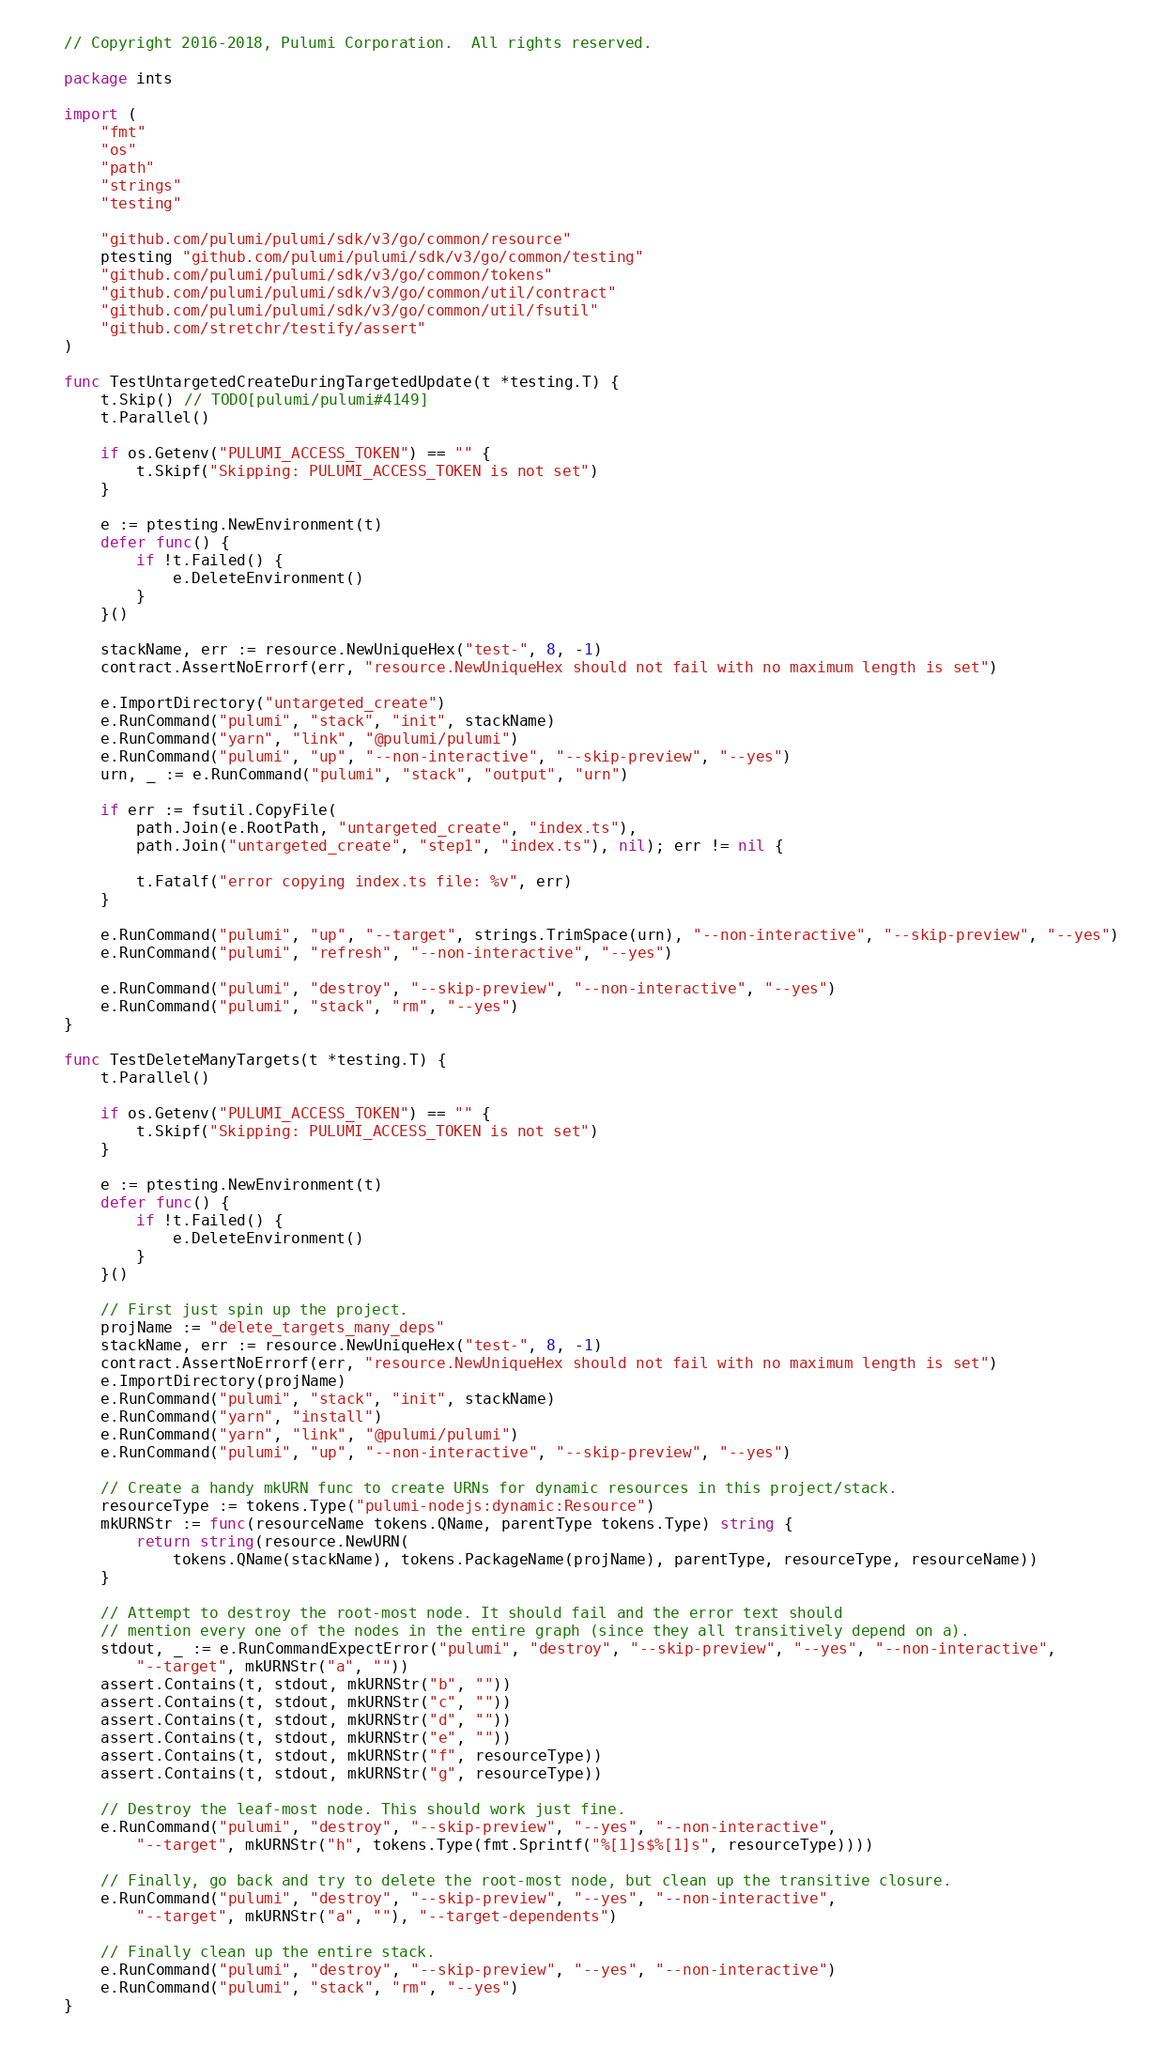Convert code to text. <code><loc_0><loc_0><loc_500><loc_500><_Go_>// Copyright 2016-2018, Pulumi Corporation.  All rights reserved.

package ints

import (
	"fmt"
	"os"
	"path"
	"strings"
	"testing"

	"github.com/pulumi/pulumi/sdk/v3/go/common/resource"
	ptesting "github.com/pulumi/pulumi/sdk/v3/go/common/testing"
	"github.com/pulumi/pulumi/sdk/v3/go/common/tokens"
	"github.com/pulumi/pulumi/sdk/v3/go/common/util/contract"
	"github.com/pulumi/pulumi/sdk/v3/go/common/util/fsutil"
	"github.com/stretchr/testify/assert"
)

func TestUntargetedCreateDuringTargetedUpdate(t *testing.T) {
	t.Skip() // TODO[pulumi/pulumi#4149]
	t.Parallel()

	if os.Getenv("PULUMI_ACCESS_TOKEN") == "" {
		t.Skipf("Skipping: PULUMI_ACCESS_TOKEN is not set")
	}

	e := ptesting.NewEnvironment(t)
	defer func() {
		if !t.Failed() {
			e.DeleteEnvironment()
		}
	}()

	stackName, err := resource.NewUniqueHex("test-", 8, -1)
	contract.AssertNoErrorf(err, "resource.NewUniqueHex should not fail with no maximum length is set")

	e.ImportDirectory("untargeted_create")
	e.RunCommand("pulumi", "stack", "init", stackName)
	e.RunCommand("yarn", "link", "@pulumi/pulumi")
	e.RunCommand("pulumi", "up", "--non-interactive", "--skip-preview", "--yes")
	urn, _ := e.RunCommand("pulumi", "stack", "output", "urn")

	if err := fsutil.CopyFile(
		path.Join(e.RootPath, "untargeted_create", "index.ts"),
		path.Join("untargeted_create", "step1", "index.ts"), nil); err != nil {

		t.Fatalf("error copying index.ts file: %v", err)
	}

	e.RunCommand("pulumi", "up", "--target", strings.TrimSpace(urn), "--non-interactive", "--skip-preview", "--yes")
	e.RunCommand("pulumi", "refresh", "--non-interactive", "--yes")

	e.RunCommand("pulumi", "destroy", "--skip-preview", "--non-interactive", "--yes")
	e.RunCommand("pulumi", "stack", "rm", "--yes")
}

func TestDeleteManyTargets(t *testing.T) {
	t.Parallel()

	if os.Getenv("PULUMI_ACCESS_TOKEN") == "" {
		t.Skipf("Skipping: PULUMI_ACCESS_TOKEN is not set")
	}

	e := ptesting.NewEnvironment(t)
	defer func() {
		if !t.Failed() {
			e.DeleteEnvironment()
		}
	}()

	// First just spin up the project.
	projName := "delete_targets_many_deps"
	stackName, err := resource.NewUniqueHex("test-", 8, -1)
	contract.AssertNoErrorf(err, "resource.NewUniqueHex should not fail with no maximum length is set")
	e.ImportDirectory(projName)
	e.RunCommand("pulumi", "stack", "init", stackName)
	e.RunCommand("yarn", "install")
	e.RunCommand("yarn", "link", "@pulumi/pulumi")
	e.RunCommand("pulumi", "up", "--non-interactive", "--skip-preview", "--yes")

	// Create a handy mkURN func to create URNs for dynamic resources in this project/stack.
	resourceType := tokens.Type("pulumi-nodejs:dynamic:Resource")
	mkURNStr := func(resourceName tokens.QName, parentType tokens.Type) string {
		return string(resource.NewURN(
			tokens.QName(stackName), tokens.PackageName(projName), parentType, resourceType, resourceName))
	}

	// Attempt to destroy the root-most node. It should fail and the error text should
	// mention every one of the nodes in the entire graph (since they all transitively depend on a).
	stdout, _ := e.RunCommandExpectError("pulumi", "destroy", "--skip-preview", "--yes", "--non-interactive",
		"--target", mkURNStr("a", ""))
	assert.Contains(t, stdout, mkURNStr("b", ""))
	assert.Contains(t, stdout, mkURNStr("c", ""))
	assert.Contains(t, stdout, mkURNStr("d", ""))
	assert.Contains(t, stdout, mkURNStr("e", ""))
	assert.Contains(t, stdout, mkURNStr("f", resourceType))
	assert.Contains(t, stdout, mkURNStr("g", resourceType))

	// Destroy the leaf-most node. This should work just fine.
	e.RunCommand("pulumi", "destroy", "--skip-preview", "--yes", "--non-interactive",
		"--target", mkURNStr("h", tokens.Type(fmt.Sprintf("%[1]s$%[1]s", resourceType))))

	// Finally, go back and try to delete the root-most node, but clean up the transitive closure.
	e.RunCommand("pulumi", "destroy", "--skip-preview", "--yes", "--non-interactive",
		"--target", mkURNStr("a", ""), "--target-dependents")

	// Finally clean up the entire stack.
	e.RunCommand("pulumi", "destroy", "--skip-preview", "--yes", "--non-interactive")
	e.RunCommand("pulumi", "stack", "rm", "--yes")
}
</code> 